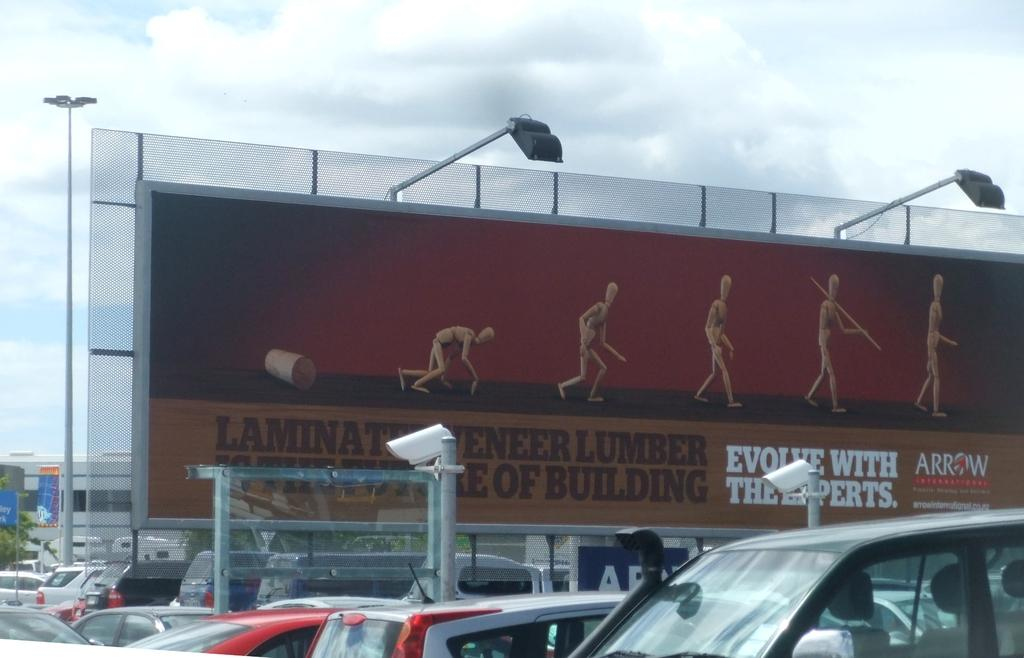<image>
Offer a succinct explanation of the picture presented. A billboard displays evolution stages advertising a lumber company. 